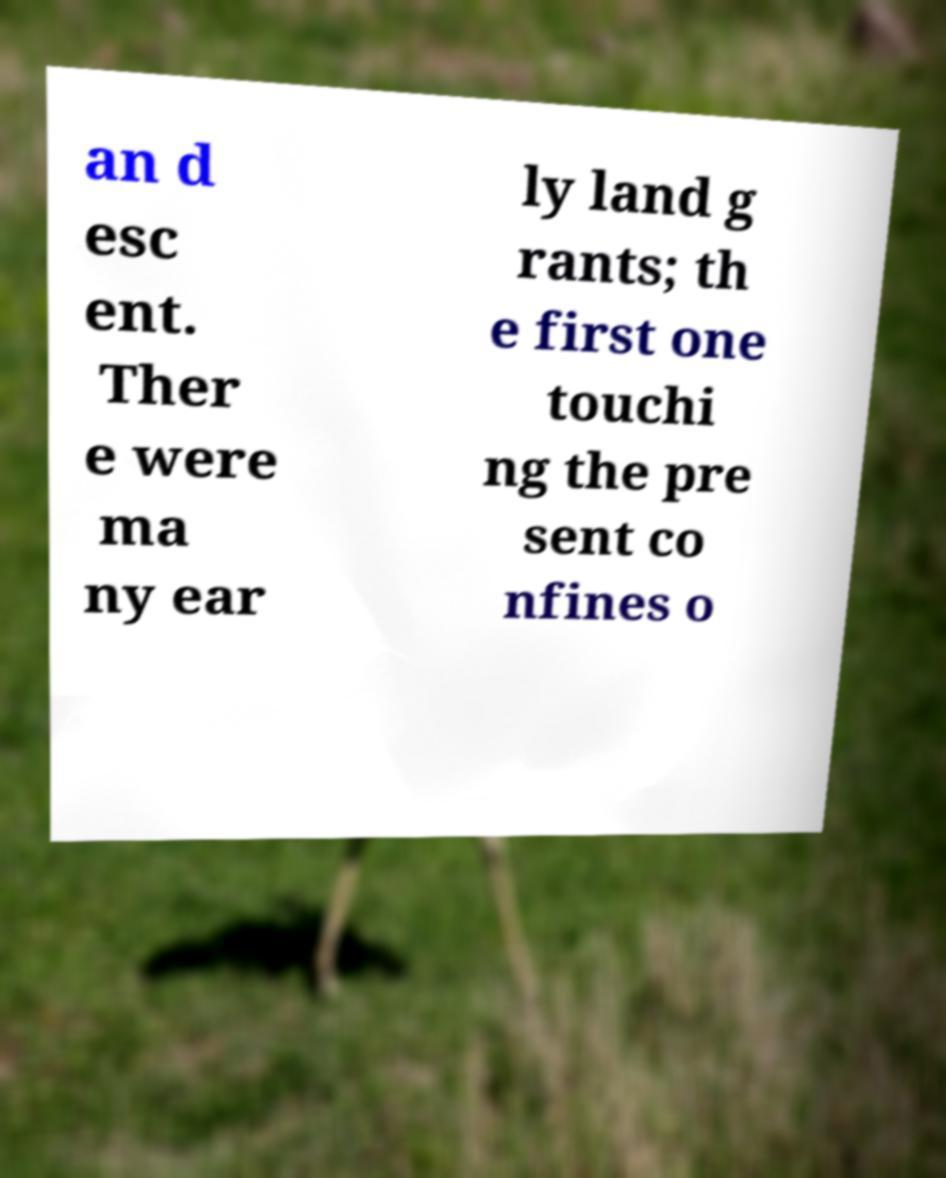For documentation purposes, I need the text within this image transcribed. Could you provide that? an d esc ent. Ther e were ma ny ear ly land g rants; th e first one touchi ng the pre sent co nfines o 